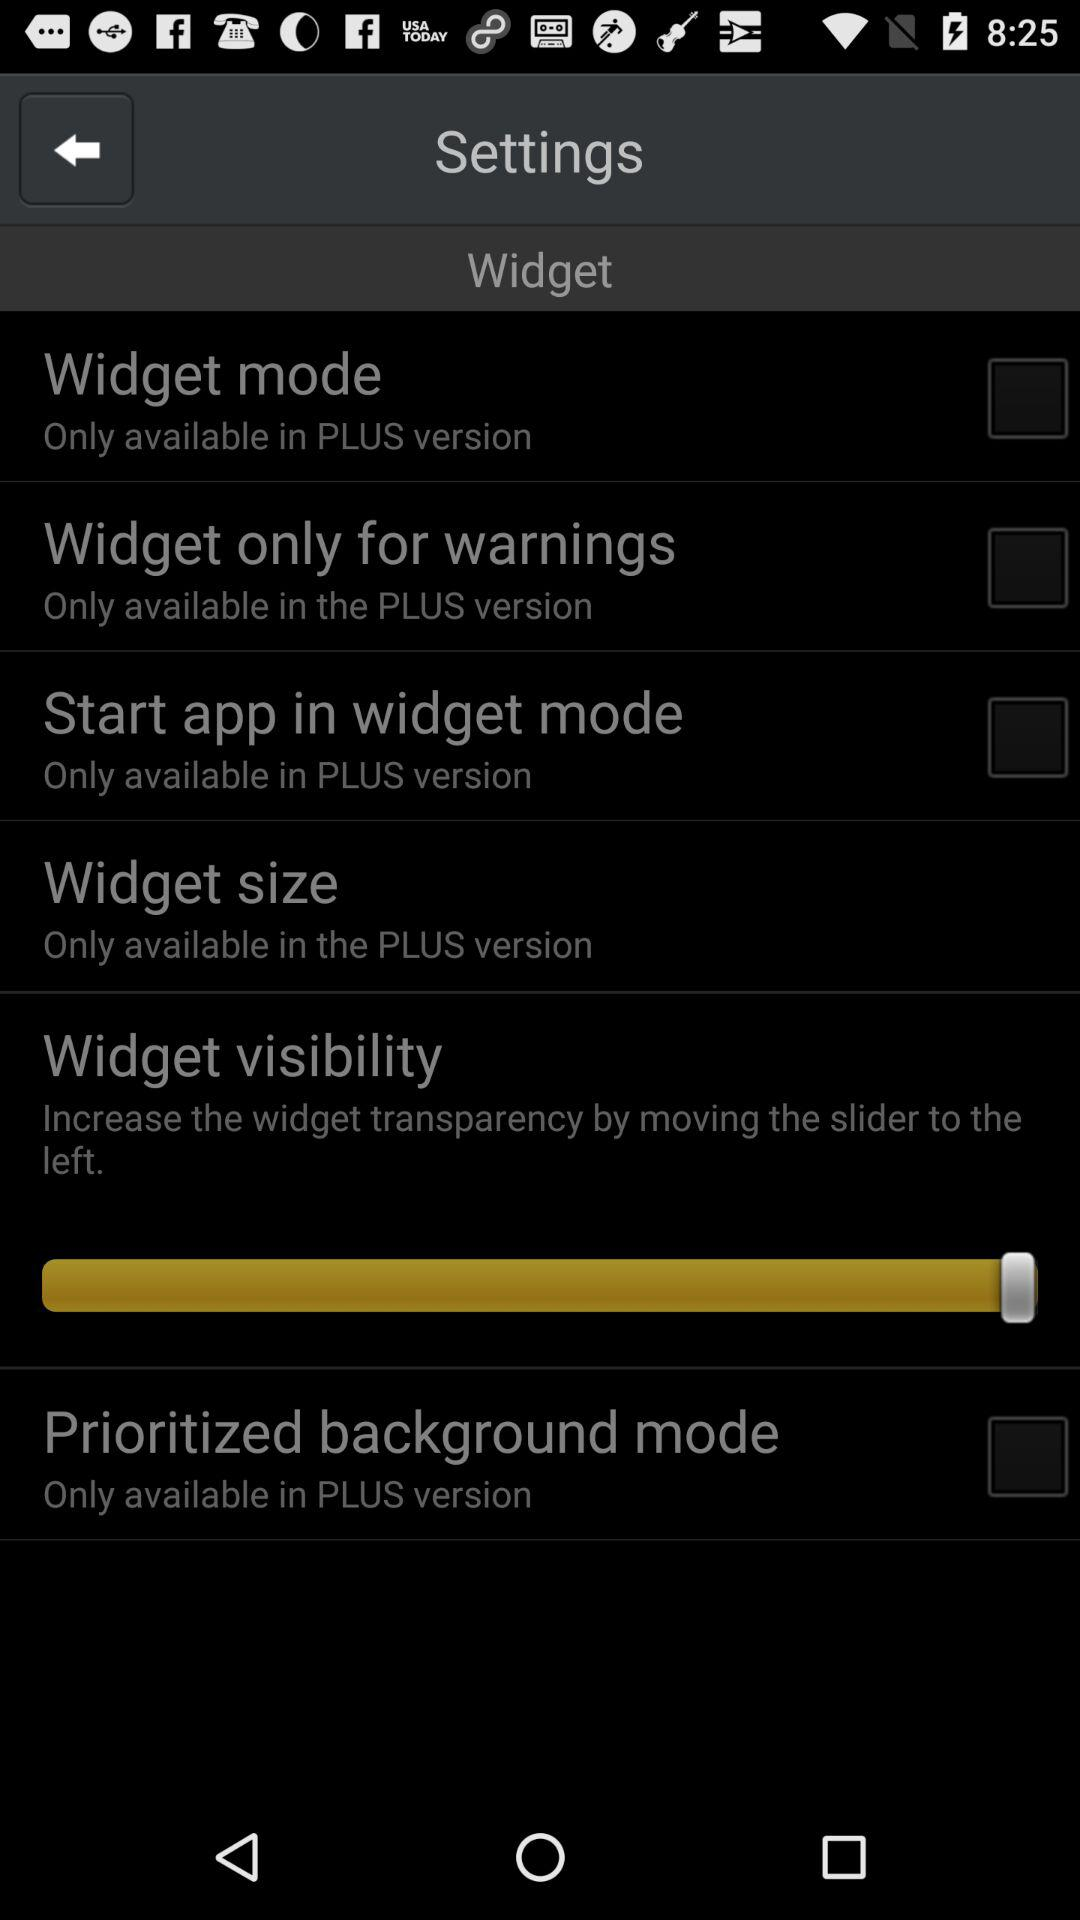In which version is the widget for warnings only available? The widget for warnings only is available in the PLUS version. 